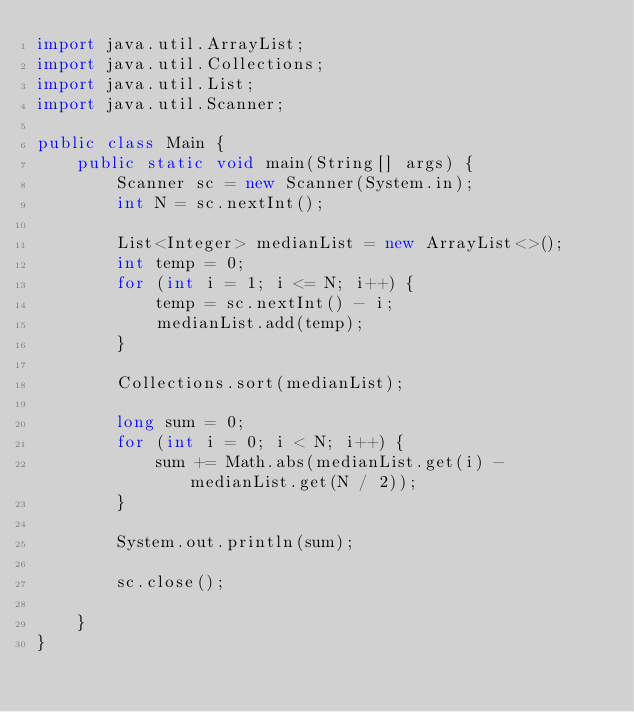Convert code to text. <code><loc_0><loc_0><loc_500><loc_500><_Java_>import java.util.ArrayList;
import java.util.Collections;
import java.util.List;
import java.util.Scanner;

public class Main {
    public static void main(String[] args) {
        Scanner sc = new Scanner(System.in);
        int N = sc.nextInt();

        List<Integer> medianList = new ArrayList<>();
        int temp = 0;
        for (int i = 1; i <= N; i++) {
            temp = sc.nextInt() - i;
            medianList.add(temp);
        }

        Collections.sort(medianList);

        long sum = 0;
        for (int i = 0; i < N; i++) {
            sum += Math.abs(medianList.get(i) - medianList.get(N / 2));
        }

        System.out.println(sum);

        sc.close();

    }
}
</code> 